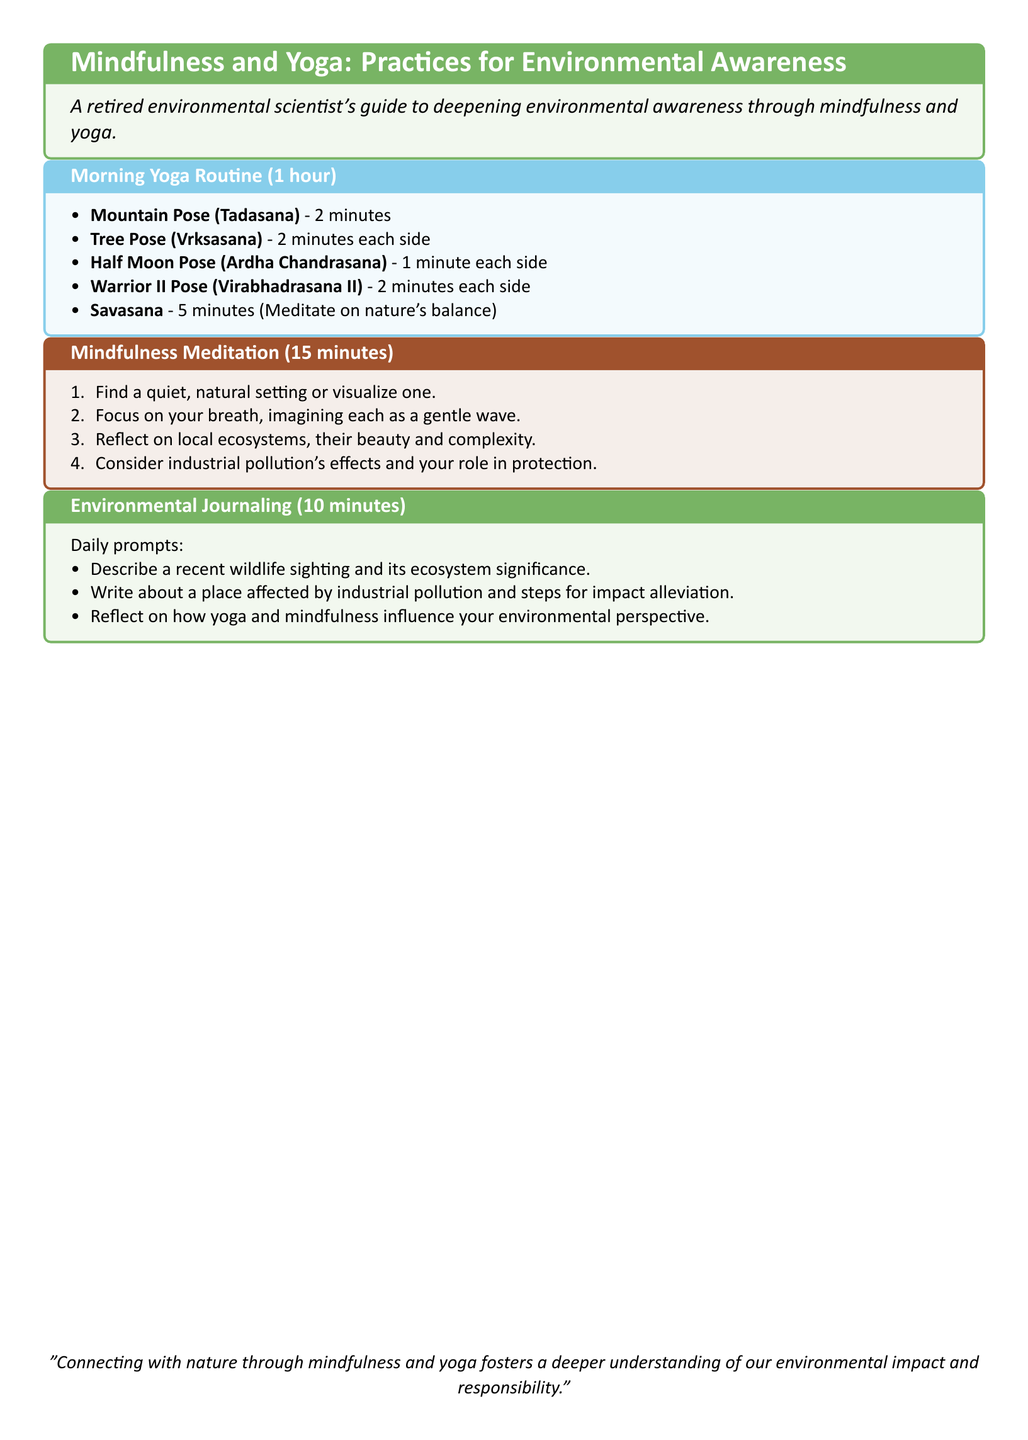What is the title of the document? The title is stated prominently at the beginning of the document, summarizing the focus on mindfulness and yoga for environmental awareness.
Answer: Mindfulness and Yoga: Practices for Environmental Awareness How long is the Morning Yoga Routine? The duration of the morning yoga routine is clearly specified in the section title.
Answer: 1 hour Which pose is practiced for 5 minutes? The duration of Savasana is mentioned as part of the Morning Yoga Routine, where it also suggests a meditative focus.
Answer: Savasana What is the duration of the Mindfulness Meditation? The duration of the mindfulness meditation is indicated explicitly in its section title.
Answer: 15 minutes What should you reflect on during mindfulness meditation? The document includes specific prompts for reflection during meditation, highlighting the relationship between personal actions and environmental issues.
Answer: Industrial pollution's effects and your role in protection What activity is done for 10 minutes daily? The section specifies that Environmental Journaling is a daily activity with a stated duration.
Answer: Environmental Journaling What does the morning yoga routine start with? The first item listed in the Morning Yoga Routine outlines the initial pose to be practiced, as clearly stated in the itemization.
Answer: Mountain Pose (Tadasana) How many prompts are provided for Environmental Journaling? The document lists several prompts for journaling in a structured format which can be counted.
Answer: Three prompts What is one benefit of connecting with nature as stated in the document? A quote at the end of the document summarizes a key benefit of the practices described within.
Answer: Deeper understanding of our environmental impact and responsibility 